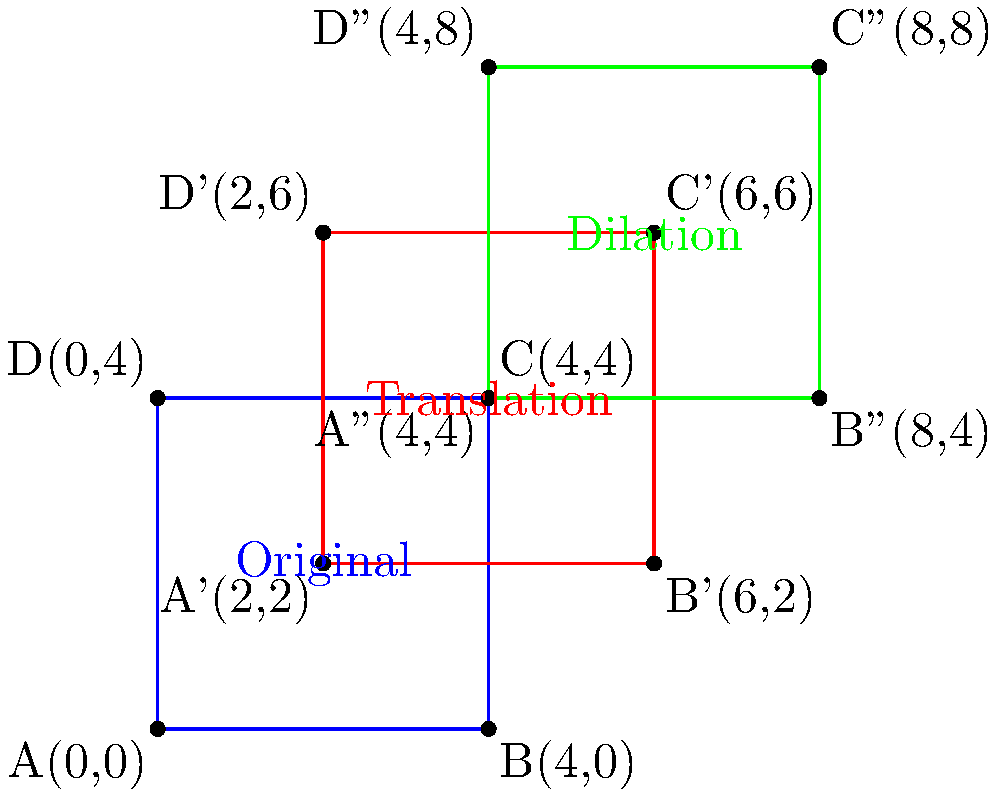In the magical realm of fantasy literature, a wizard's tower undergoes a series of transformations. The tower's original position is represented by the blue square with vertices A(0,0), B(4,0), C(4,4), and D(0,4). First, the tower is translated 2 units right and 2 units up (red square). Then, it is dilated by a scale factor of 1.5 from the point (0,0) (green square). What are the coordinates of vertex C after these transformations? Let's approach this step-by-step:

1) First Translation:
   - The tower is moved 2 units right and 2 units up.
   - This means we add 2 to both x and y coordinates.
   - C(4,4) becomes C'(6,6)

2) Dilation:
   - The dilation has a scale factor of 1.5 from the point (0,0).
   - To dilate a point, we multiply its coordinates by the scale factor.
   - C'(6,6) becomes C''(6 * 1.5, 6 * 1.5) = C''(9,9)

Therefore, after both transformations, vertex C ends up at (9,9).
Answer: (9,9) 